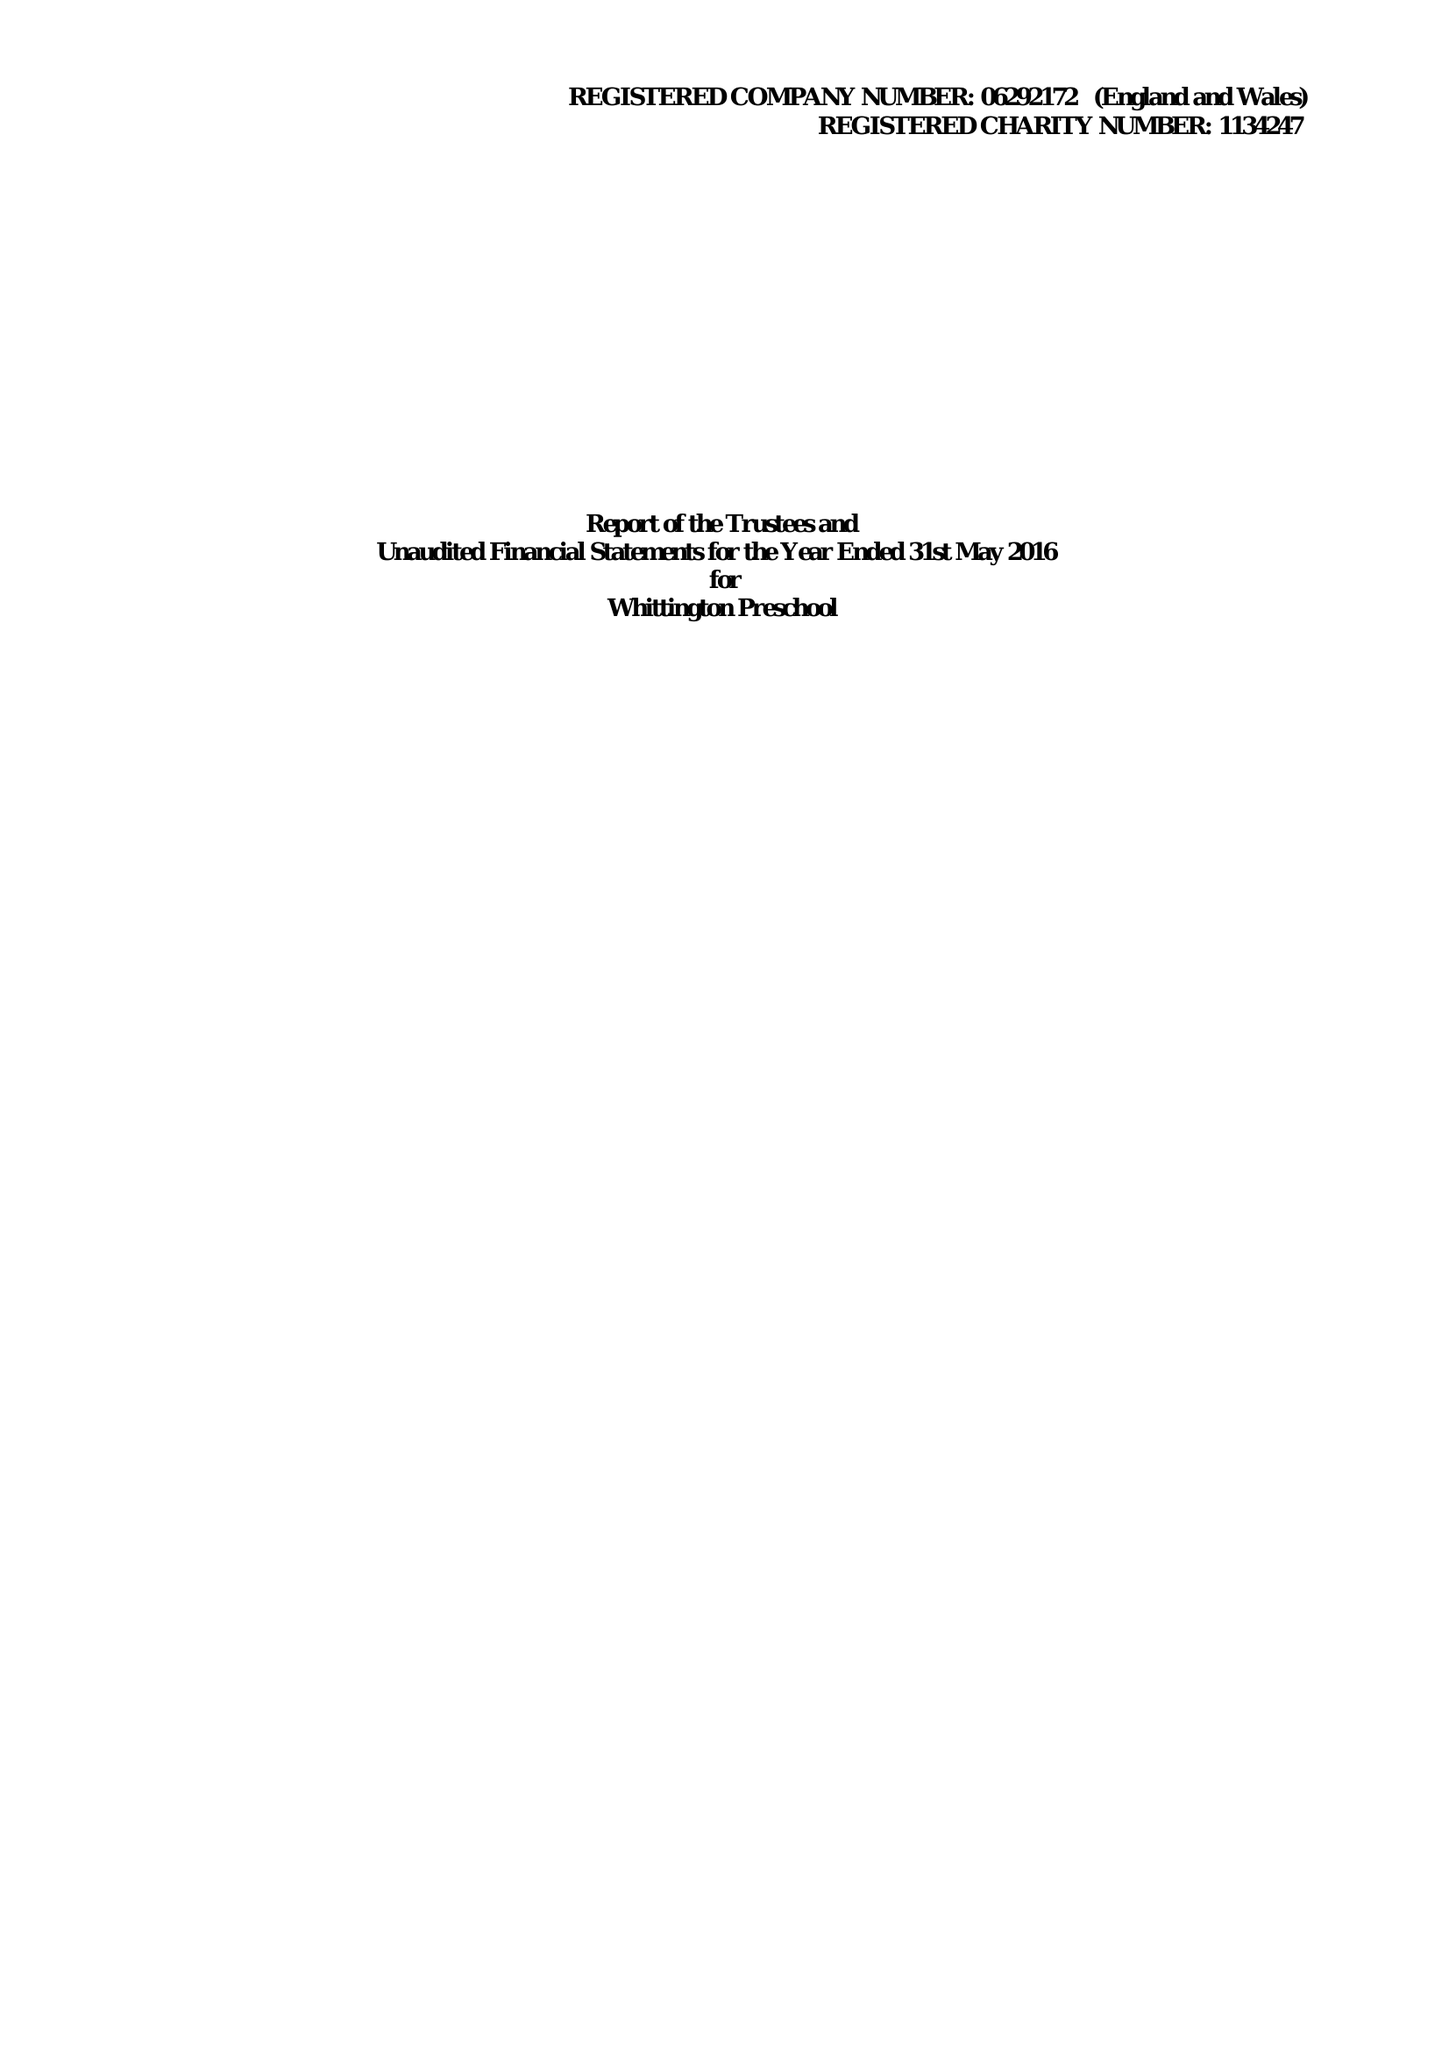What is the value for the address__street_line?
Answer the question using a single word or phrase. WHITTINGTON 